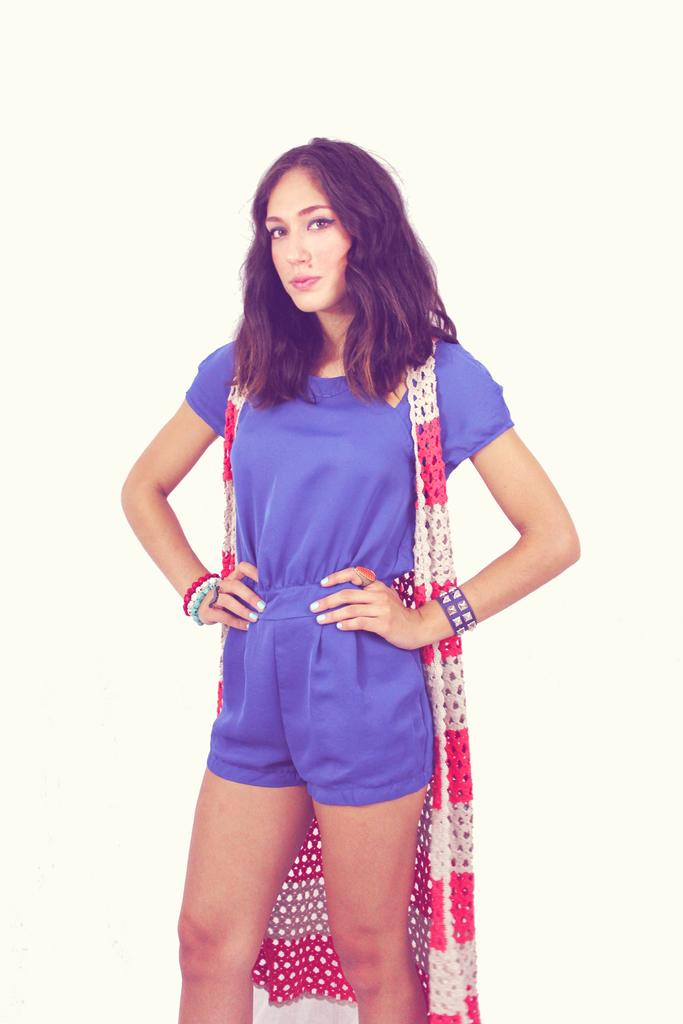What is the main subject of the image? The main subject of the image is a woman. What expression does the woman have in the image? The woman is smiling in the image. What color is the background of the image? The background of the image is cream-colored. What type of cast can be seen on the woman's leg in the image? There is no cast visible on the woman's leg in the image. What type of boot is the woman wearing in the image? There is no boot visible on the woman in the image. 